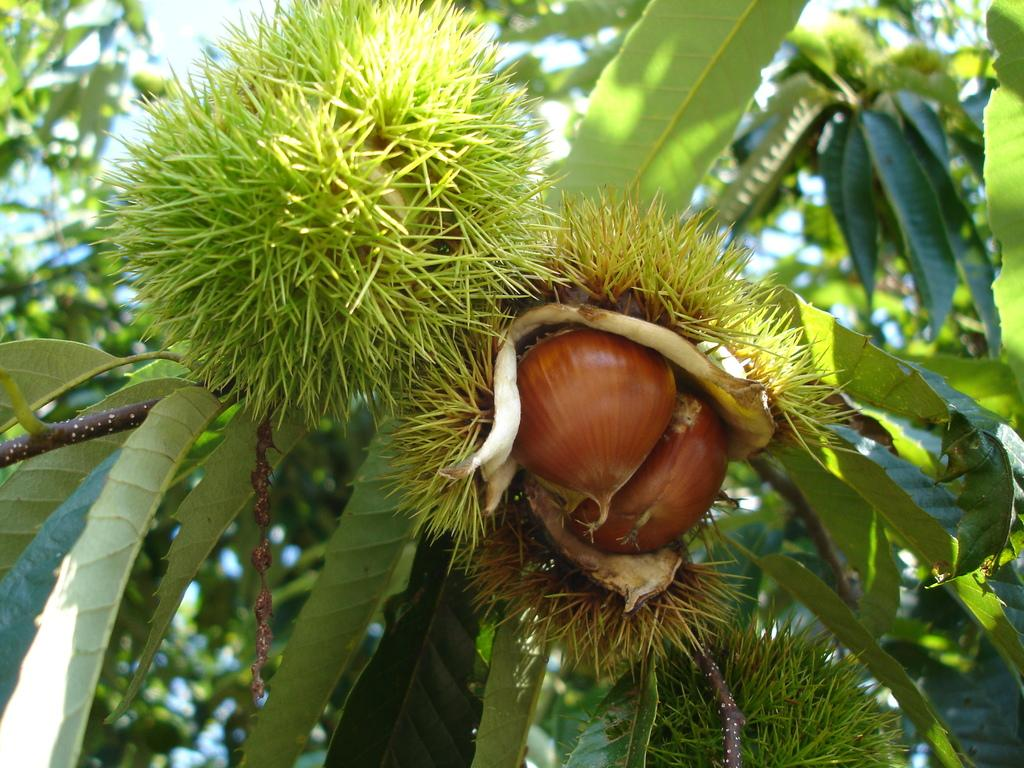What type of plants or trees are present in the image? There are plants or trees with fruits in the image. What can be seen in the background of the image? There are trees in the background of the image. How would you describe the background of the image? The background of the image is blurred. What type of pet can be seen playing with a whistle in the image? There is no pet or whistle present in the image; it features plants or trees with fruits and a blurred background. 